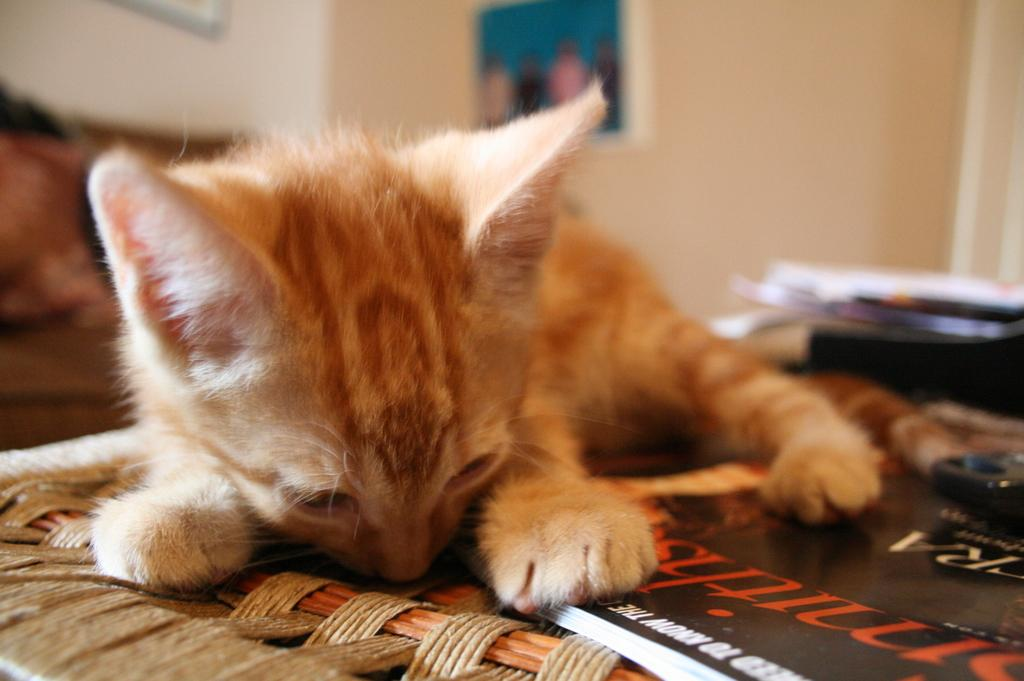What type of animal can be seen in the image? There is a cat in the image. What object is on the table in the image? There is a book on the table in the image. What can be seen in the background of the image? There are items visible in the background of the image. What type of decorations are on the walls in the image? There are photo frames on the walls in the image. What type of stamp can be seen on the cat's paw in the image? There is no stamp present on the cat's paw in the image. What type of straw is the cat using to drink from the book in the image? There is no straw present in the image, and the cat is not drinking from the book. 